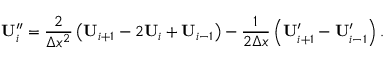<formula> <loc_0><loc_0><loc_500><loc_500>U _ { i } ^ { \prime \prime } = \frac { 2 } { \Delta x ^ { 2 } } \left ( U _ { i + 1 } - 2 U _ { i } + U _ { i - 1 } \right ) - \frac { 1 } { 2 \Delta x } \left ( U _ { i + 1 } ^ { \prime } - U _ { i - 1 } ^ { \prime } \right ) .</formula> 